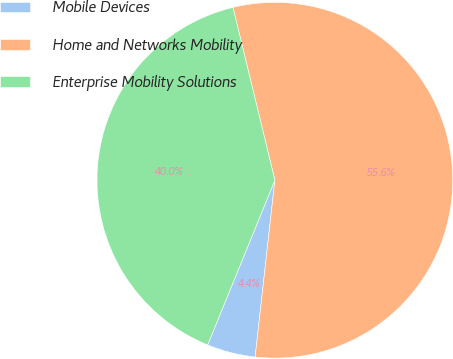Convert chart to OTSL. <chart><loc_0><loc_0><loc_500><loc_500><pie_chart><fcel>Mobile Devices<fcel>Home and Networks Mobility<fcel>Enterprise Mobility Solutions<nl><fcel>4.4%<fcel>55.56%<fcel>40.05%<nl></chart> 